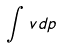<formula> <loc_0><loc_0><loc_500><loc_500>\int v d p</formula> 